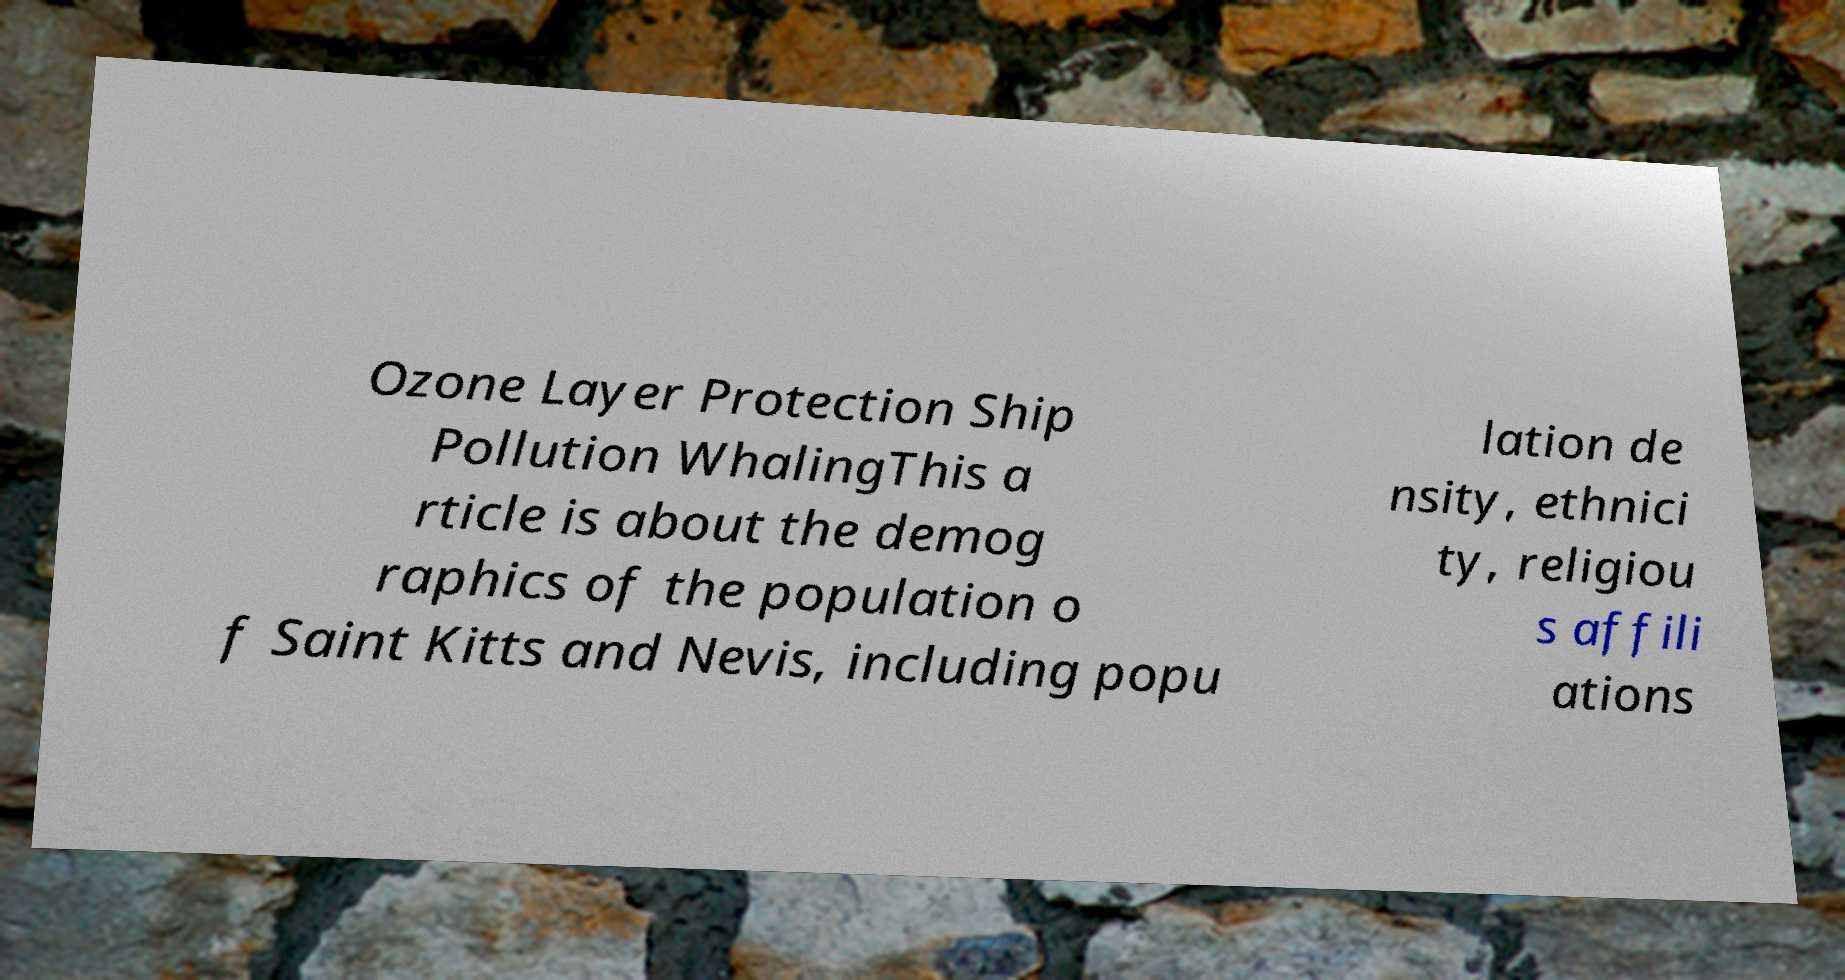What messages or text are displayed in this image? I need them in a readable, typed format. Ozone Layer Protection Ship Pollution WhalingThis a rticle is about the demog raphics of the population o f Saint Kitts and Nevis, including popu lation de nsity, ethnici ty, religiou s affili ations 